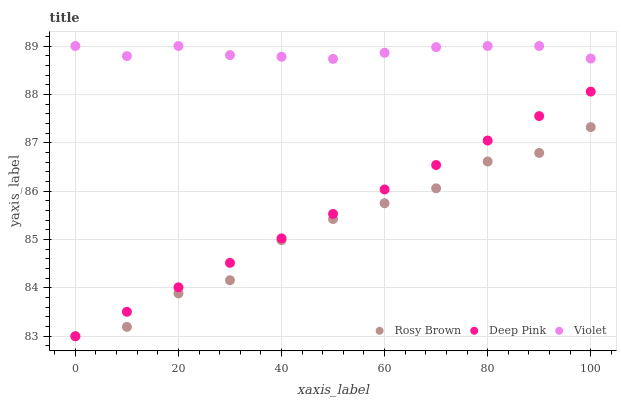Does Rosy Brown have the minimum area under the curve?
Answer yes or no. Yes. Does Violet have the maximum area under the curve?
Answer yes or no. Yes. Does Deep Pink have the minimum area under the curve?
Answer yes or no. No. Does Deep Pink have the maximum area under the curve?
Answer yes or no. No. Is Deep Pink the smoothest?
Answer yes or no. Yes. Is Rosy Brown the roughest?
Answer yes or no. Yes. Is Violet the smoothest?
Answer yes or no. No. Is Violet the roughest?
Answer yes or no. No. Does Rosy Brown have the lowest value?
Answer yes or no. Yes. Does Violet have the lowest value?
Answer yes or no. No. Does Violet have the highest value?
Answer yes or no. Yes. Does Deep Pink have the highest value?
Answer yes or no. No. Is Deep Pink less than Violet?
Answer yes or no. Yes. Is Violet greater than Rosy Brown?
Answer yes or no. Yes. Does Deep Pink intersect Rosy Brown?
Answer yes or no. Yes. Is Deep Pink less than Rosy Brown?
Answer yes or no. No. Is Deep Pink greater than Rosy Brown?
Answer yes or no. No. Does Deep Pink intersect Violet?
Answer yes or no. No. 